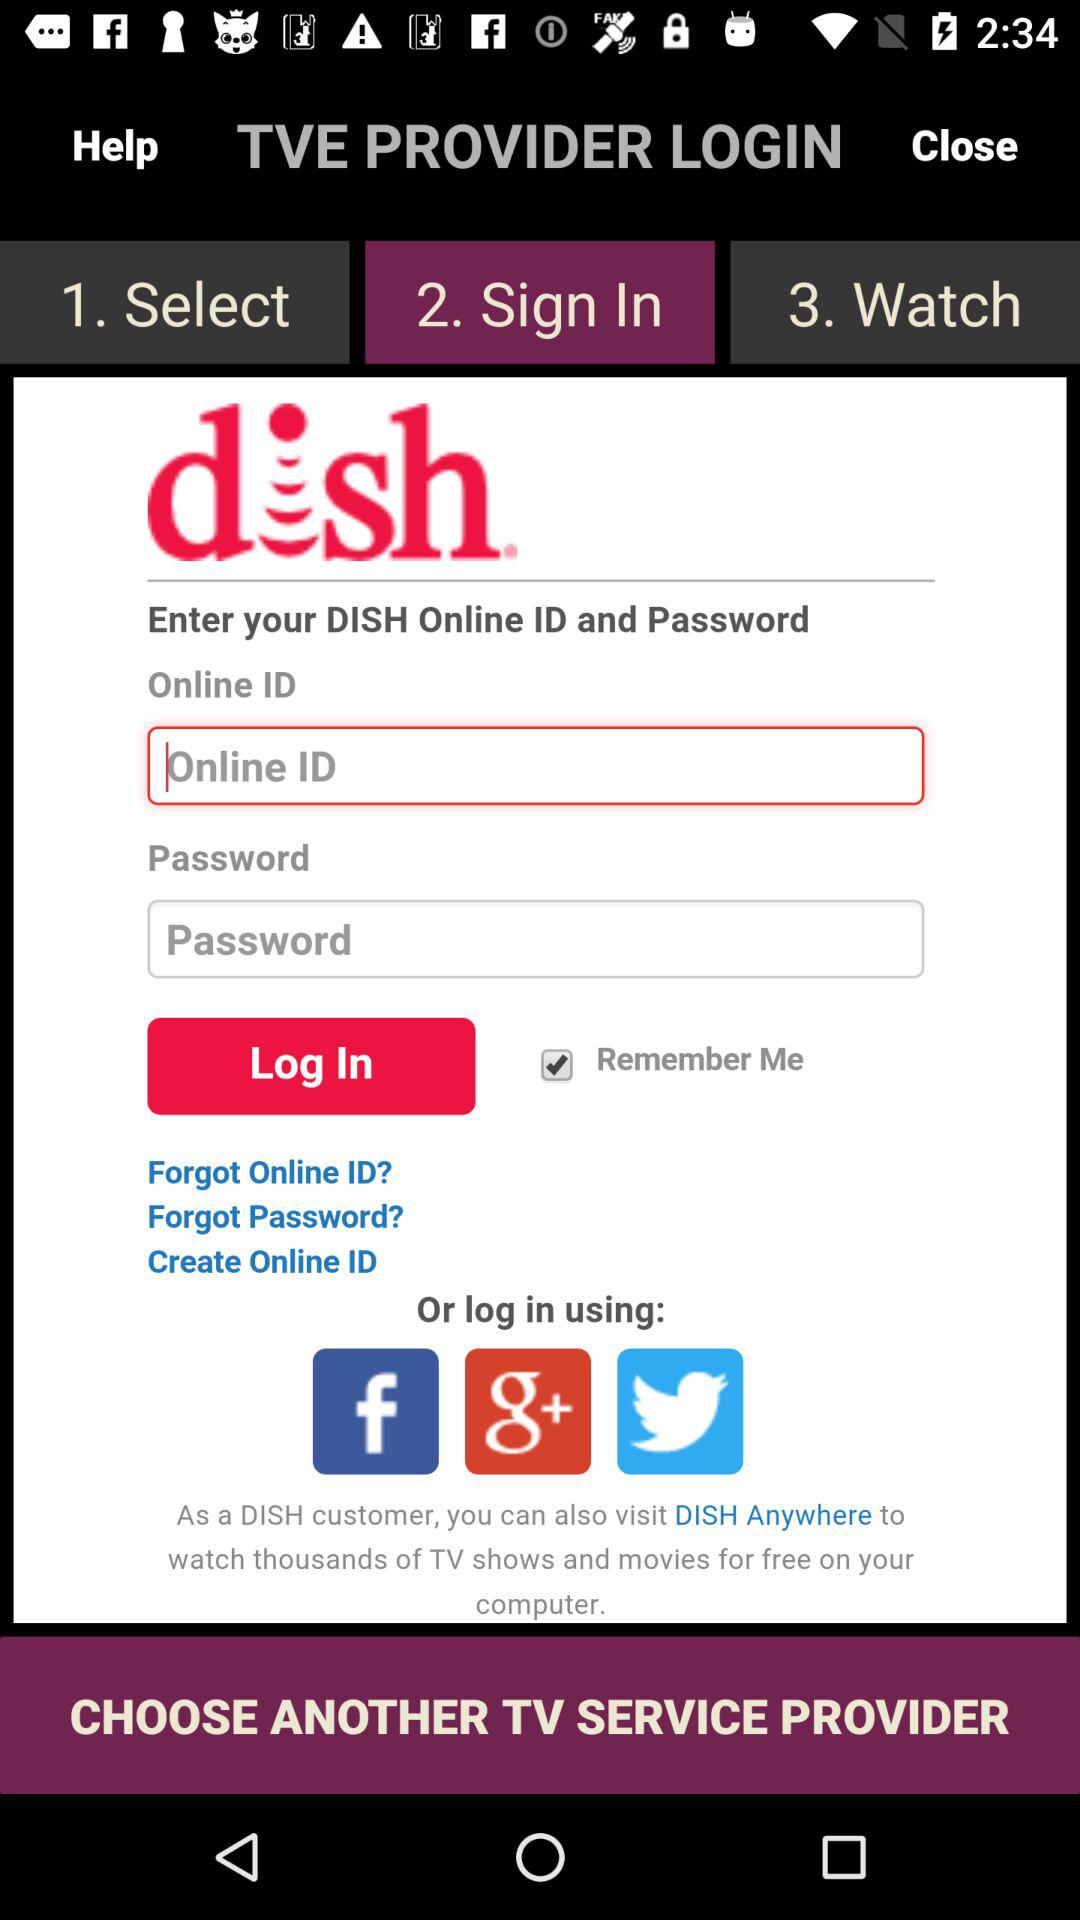What are the other login applications? The other login applications are "Facebook", "Google+" and "Twitter". 